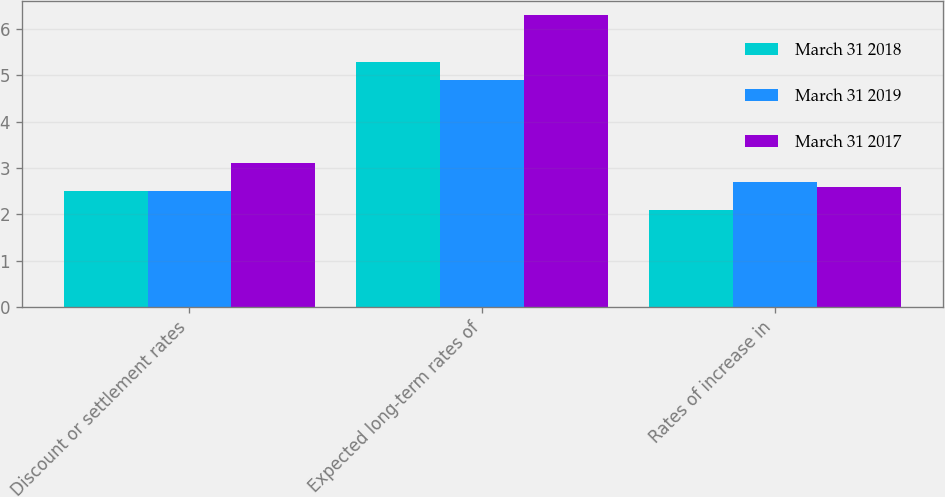<chart> <loc_0><loc_0><loc_500><loc_500><stacked_bar_chart><ecel><fcel>Discount or settlement rates<fcel>Expected long-term rates of<fcel>Rates of increase in<nl><fcel>March 31 2018<fcel>2.5<fcel>5.3<fcel>2.1<nl><fcel>March 31 2019<fcel>2.5<fcel>4.9<fcel>2.7<nl><fcel>March 31 2017<fcel>3.1<fcel>6.3<fcel>2.6<nl></chart> 